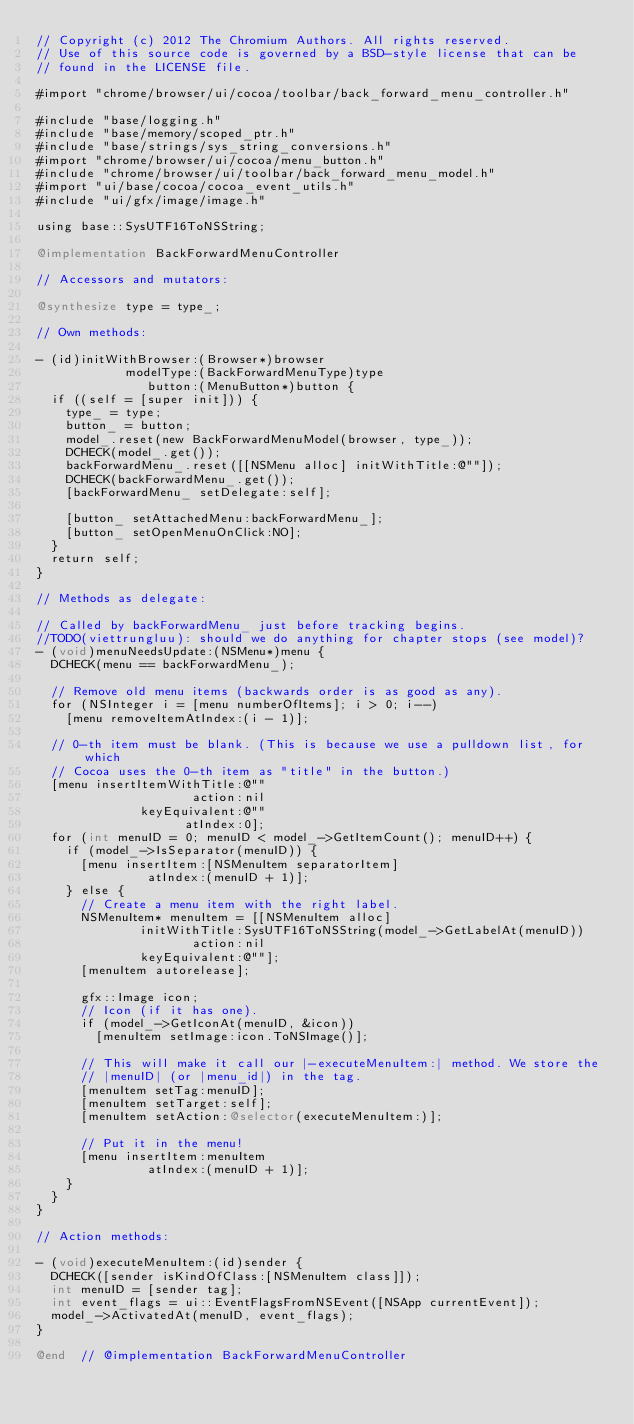<code> <loc_0><loc_0><loc_500><loc_500><_ObjectiveC_>// Copyright (c) 2012 The Chromium Authors. All rights reserved.
// Use of this source code is governed by a BSD-style license that can be
// found in the LICENSE file.

#import "chrome/browser/ui/cocoa/toolbar/back_forward_menu_controller.h"

#include "base/logging.h"
#include "base/memory/scoped_ptr.h"
#include "base/strings/sys_string_conversions.h"
#import "chrome/browser/ui/cocoa/menu_button.h"
#include "chrome/browser/ui/toolbar/back_forward_menu_model.h"
#import "ui/base/cocoa/cocoa_event_utils.h"
#include "ui/gfx/image/image.h"

using base::SysUTF16ToNSString;

@implementation BackForwardMenuController

// Accessors and mutators:

@synthesize type = type_;

// Own methods:

- (id)initWithBrowser:(Browser*)browser
            modelType:(BackForwardMenuType)type
               button:(MenuButton*)button {
  if ((self = [super init])) {
    type_ = type;
    button_ = button;
    model_.reset(new BackForwardMenuModel(browser, type_));
    DCHECK(model_.get());
    backForwardMenu_.reset([[NSMenu alloc] initWithTitle:@""]);
    DCHECK(backForwardMenu_.get());
    [backForwardMenu_ setDelegate:self];

    [button_ setAttachedMenu:backForwardMenu_];
    [button_ setOpenMenuOnClick:NO];
  }
  return self;
}

// Methods as delegate:

// Called by backForwardMenu_ just before tracking begins.
//TODO(viettrungluu): should we do anything for chapter stops (see model)?
- (void)menuNeedsUpdate:(NSMenu*)menu {
  DCHECK(menu == backForwardMenu_);

  // Remove old menu items (backwards order is as good as any).
  for (NSInteger i = [menu numberOfItems]; i > 0; i--)
    [menu removeItemAtIndex:(i - 1)];

  // 0-th item must be blank. (This is because we use a pulldown list, for which
  // Cocoa uses the 0-th item as "title" in the button.)
  [menu insertItemWithTitle:@""
                     action:nil
              keyEquivalent:@""
                    atIndex:0];
  for (int menuID = 0; menuID < model_->GetItemCount(); menuID++) {
    if (model_->IsSeparator(menuID)) {
      [menu insertItem:[NSMenuItem separatorItem]
               atIndex:(menuID + 1)];
    } else {
      // Create a menu item with the right label.
      NSMenuItem* menuItem = [[NSMenuItem alloc]
              initWithTitle:SysUTF16ToNSString(model_->GetLabelAt(menuID))
                     action:nil
              keyEquivalent:@""];
      [menuItem autorelease];

      gfx::Image icon;
      // Icon (if it has one).
      if (model_->GetIconAt(menuID, &icon))
        [menuItem setImage:icon.ToNSImage()];

      // This will make it call our |-executeMenuItem:| method. We store the
      // |menuID| (or |menu_id|) in the tag.
      [menuItem setTag:menuID];
      [menuItem setTarget:self];
      [menuItem setAction:@selector(executeMenuItem:)];

      // Put it in the menu!
      [menu insertItem:menuItem
               atIndex:(menuID + 1)];
    }
  }
}

// Action methods:

- (void)executeMenuItem:(id)sender {
  DCHECK([sender isKindOfClass:[NSMenuItem class]]);
  int menuID = [sender tag];
  int event_flags = ui::EventFlagsFromNSEvent([NSApp currentEvent]);
  model_->ActivatedAt(menuID, event_flags);
}

@end  // @implementation BackForwardMenuController
</code> 